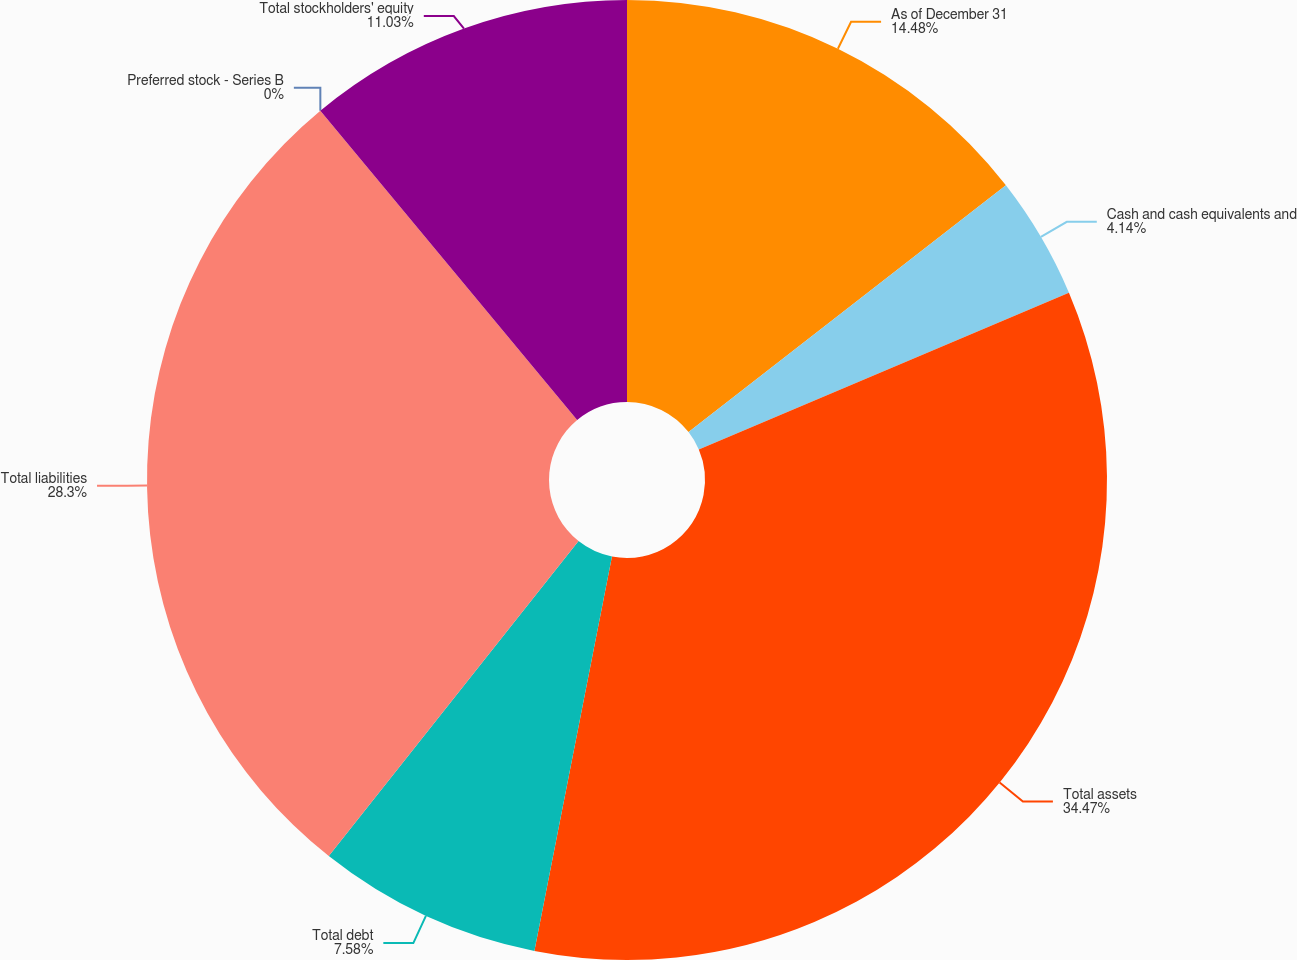<chart> <loc_0><loc_0><loc_500><loc_500><pie_chart><fcel>As of December 31<fcel>Cash and cash equivalents and<fcel>Total assets<fcel>Total debt<fcel>Total liabilities<fcel>Preferred stock - Series B<fcel>Total stockholders' equity<nl><fcel>14.48%<fcel>4.14%<fcel>34.47%<fcel>7.58%<fcel>28.3%<fcel>0.0%<fcel>11.03%<nl></chart> 